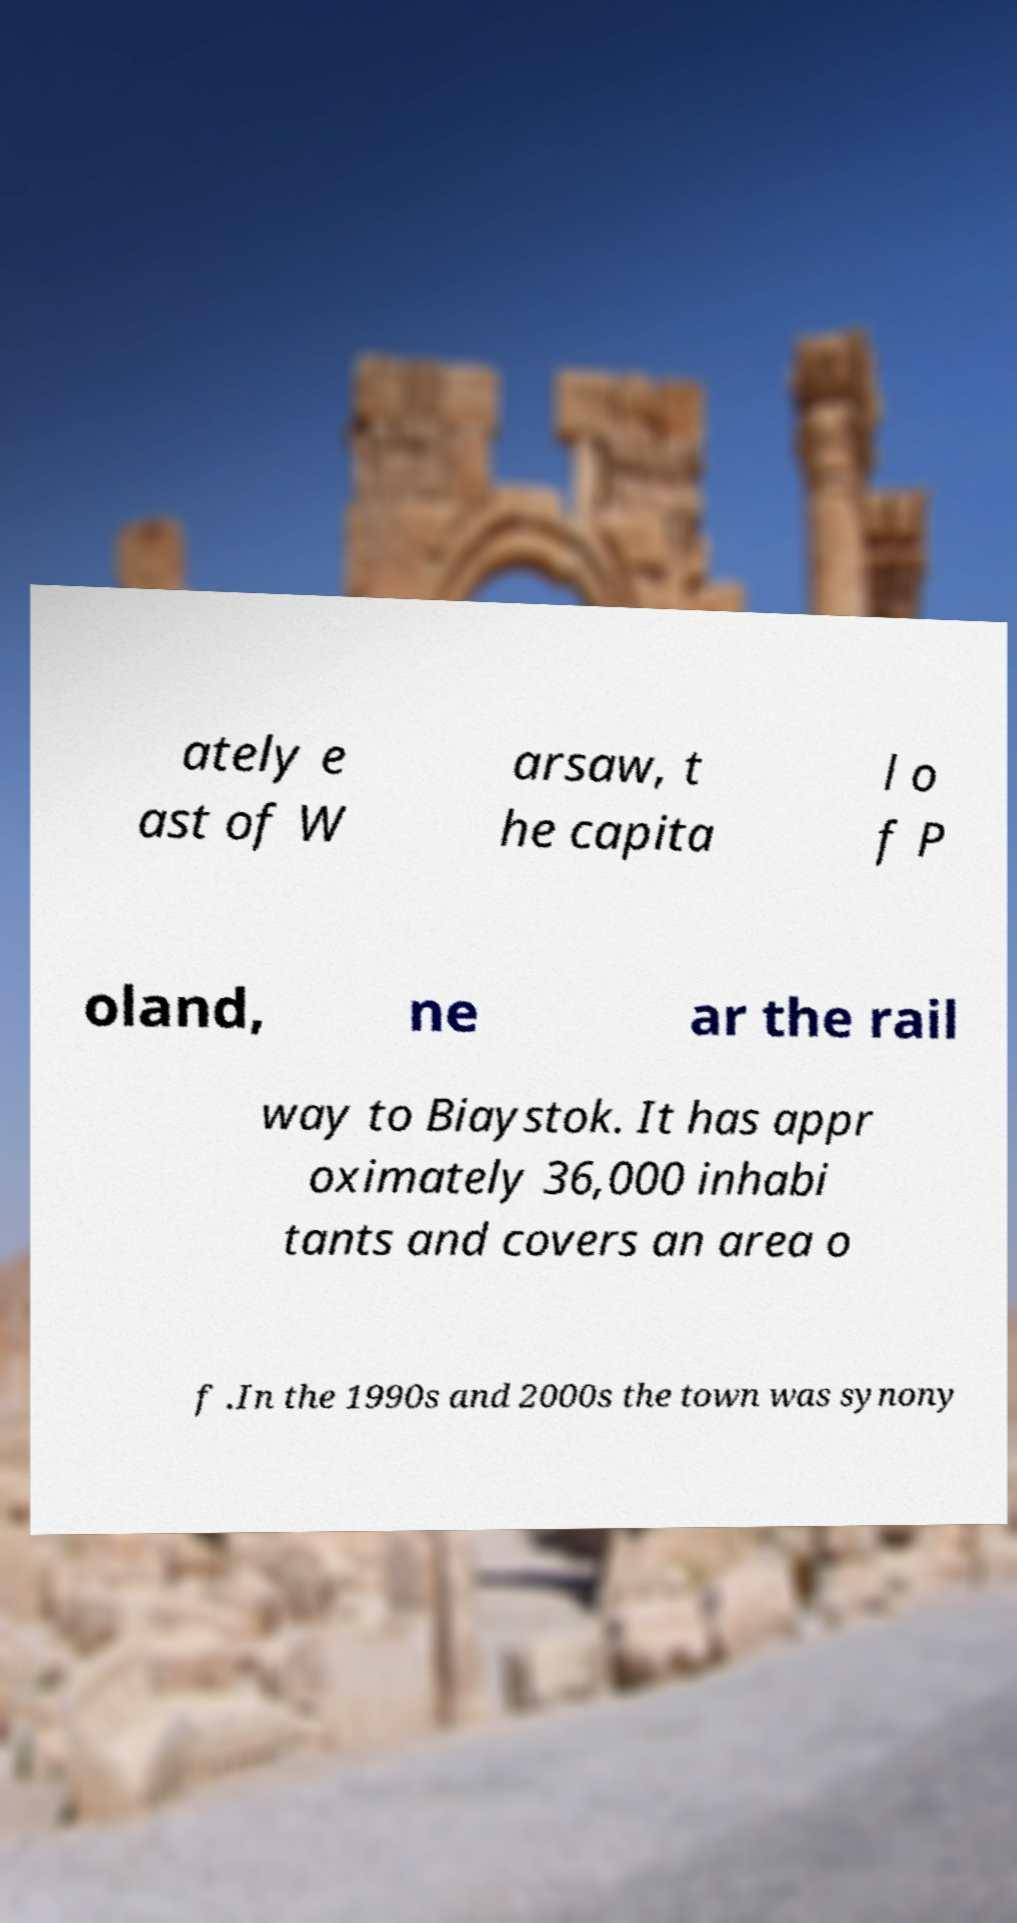What messages or text are displayed in this image? I need them in a readable, typed format. ately e ast of W arsaw, t he capita l o f P oland, ne ar the rail way to Biaystok. It has appr oximately 36,000 inhabi tants and covers an area o f .In the 1990s and 2000s the town was synony 